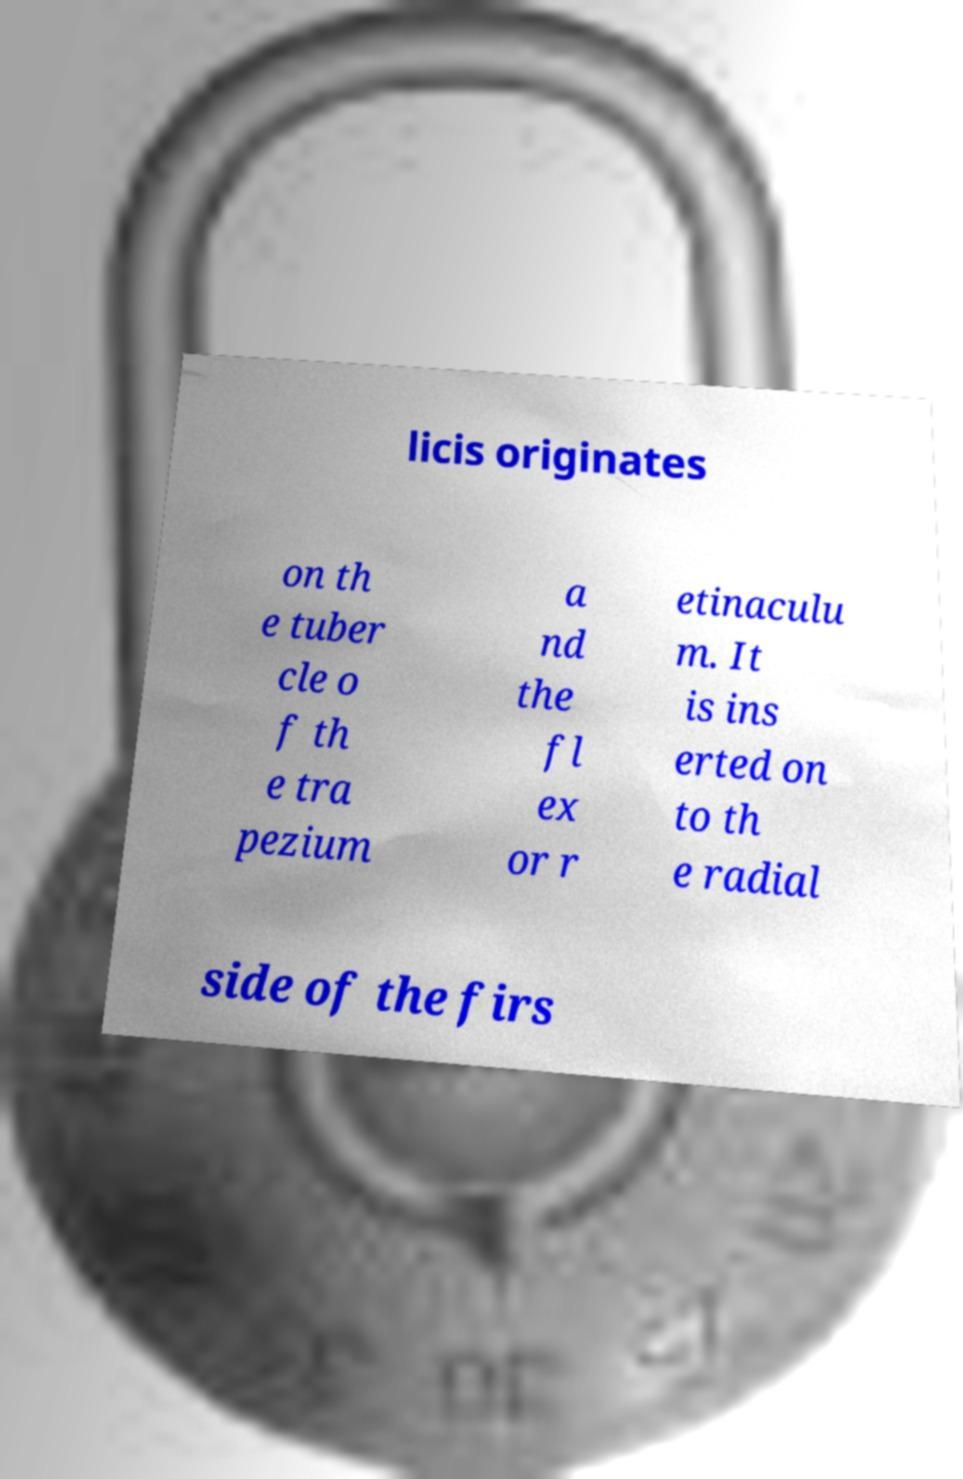Can you read and provide the text displayed in the image?This photo seems to have some interesting text. Can you extract and type it out for me? licis originates on th e tuber cle o f th e tra pezium a nd the fl ex or r etinaculu m. It is ins erted on to th e radial side of the firs 